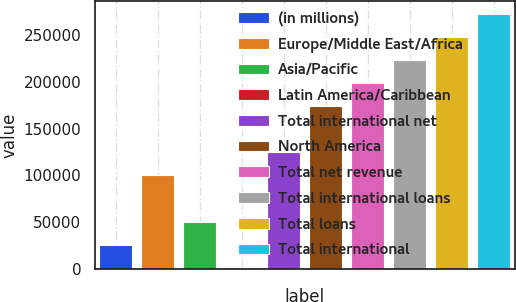Convert chart to OTSL. <chart><loc_0><loc_0><loc_500><loc_500><bar_chart><fcel>(in millions)<fcel>Europe/Middle East/Africa<fcel>Asia/Pacific<fcel>Latin America/Caribbean<fcel>Total international net<fcel>North America<fcel>Total net revenue<fcel>Total international loans<fcel>Total loans<fcel>Total international<nl><fcel>25883.7<fcel>100073<fcel>50613.4<fcel>1154<fcel>124802<fcel>174262<fcel>198992<fcel>223721<fcel>248451<fcel>273181<nl></chart> 